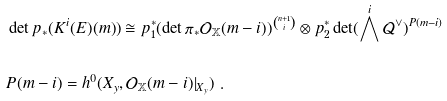<formula> <loc_0><loc_0><loc_500><loc_500>& \det p _ { * } ( K ^ { i } ( E ) ( m ) ) \cong p _ { 1 } ^ { * } ( \det \pi _ { * } \mathcal { O } _ { \mathbb { X } } ( m - i ) ) ^ { \binom { n + 1 } { i } } \otimes p _ { 2 } ^ { * } \det ( \bigwedge ^ { i } \mathcal { Q } ^ { \vee } ) ^ { P ( m - i ) } \\ \ \\ & P ( m - i ) = h ^ { 0 } ( X _ { y } , \mathcal { O } _ { \mathbb { X } } ( m - i ) | _ { X _ { y } } ) \ .</formula> 